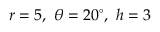<formula> <loc_0><loc_0><loc_500><loc_500>r = 5 , \ \theta = 2 0 ^ { \circ } , \ h = 3</formula> 